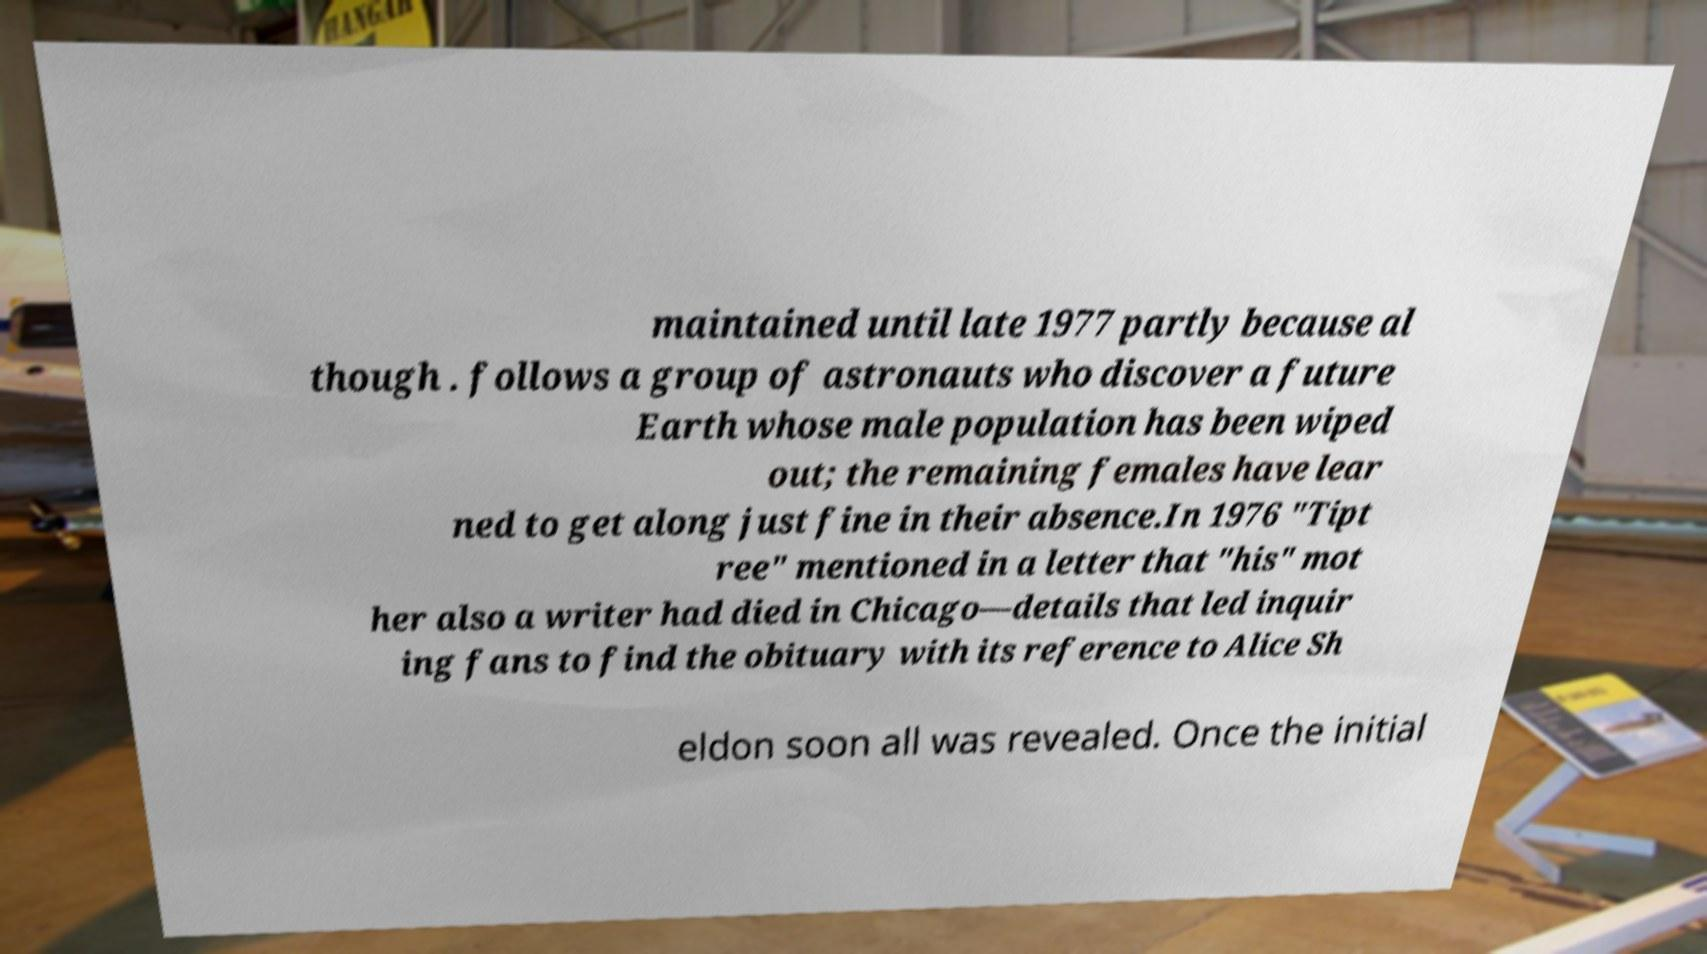Please identify and transcribe the text found in this image. maintained until late 1977 partly because al though . follows a group of astronauts who discover a future Earth whose male population has been wiped out; the remaining females have lear ned to get along just fine in their absence.In 1976 "Tipt ree" mentioned in a letter that "his" mot her also a writer had died in Chicago—details that led inquir ing fans to find the obituary with its reference to Alice Sh eldon soon all was revealed. Once the initial 